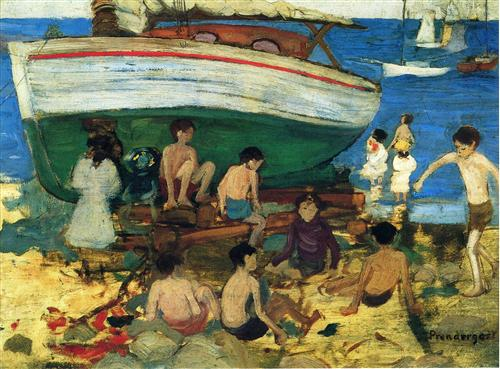Can you tell me more about the boat in the image? Certainly! The boat in the image is a prominent feature, painted with a solid structure and a vivid red roof that draws attention. It appears to be an old wooden boat, potentially a fishing vessel, given its size and design. This boat adds a nostalgic or perhaps historical dimension to the scene, suggesting the beach's possible role as a fishing or small port area in addition to its recreational use. 